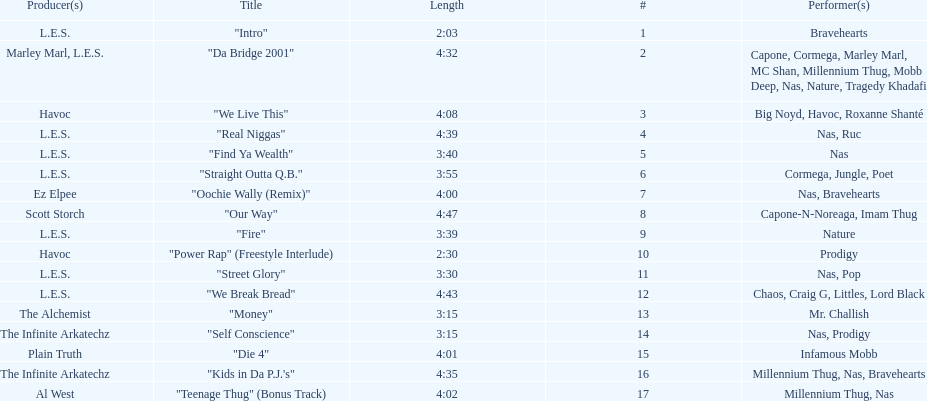What is the first song on the album produced by havoc? "We Live This". 